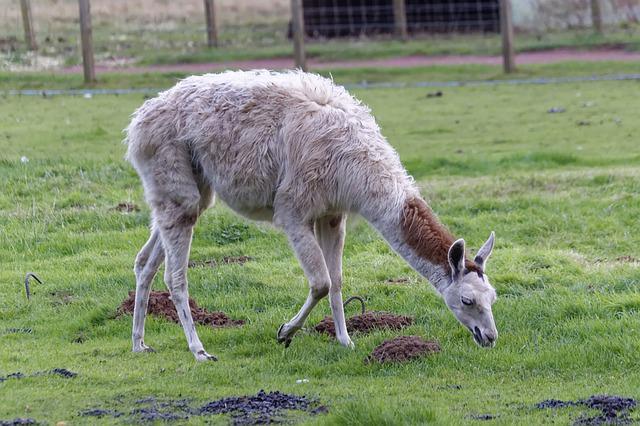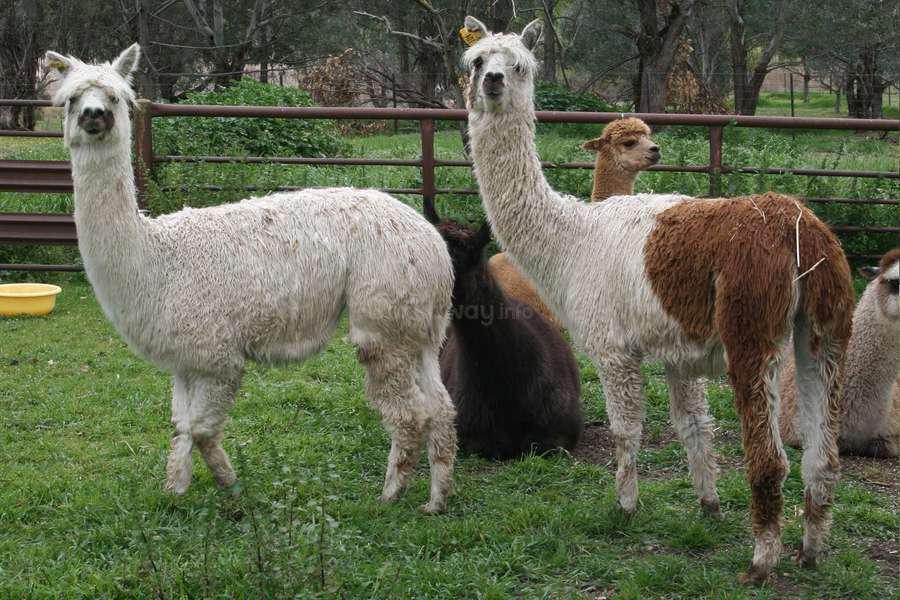The first image is the image on the left, the second image is the image on the right. Considering the images on both sides, is "Each image contains a single llama, no llama looks straight at the camera, and the llamas on the left and right share similar fur coloring and body poses." valid? Answer yes or no. No. The first image is the image on the left, the second image is the image on the right. Assess this claim about the two images: "The left and right image contains the same number of Llamas facing the same direction.". Correct or not? Answer yes or no. No. 